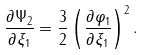Convert formula to latex. <formula><loc_0><loc_0><loc_500><loc_500>\frac { \partial \Psi _ { 2 } } { \partial \xi _ { 1 } } = \frac { 3 } { 2 } \left ( \frac { \partial \varphi _ { 1 } } { \partial \xi _ { 1 } } \right ) ^ { 2 } .</formula> 